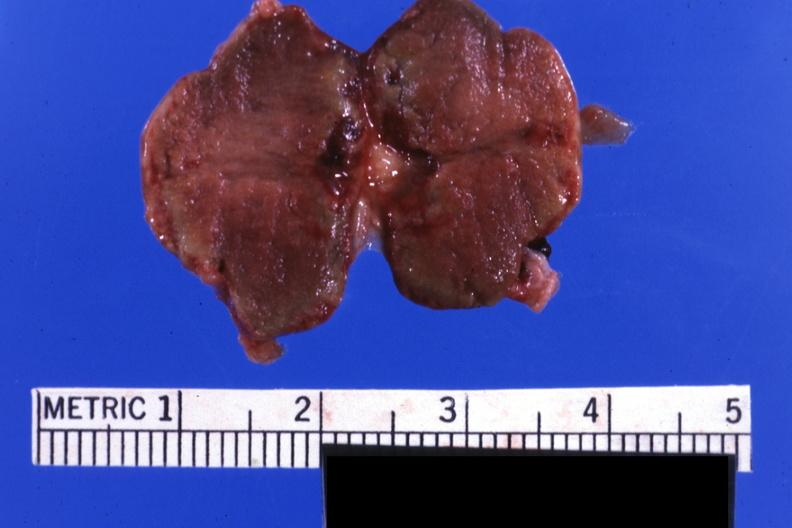what is present?
Answer the question using a single word or phrase. Pituitary 